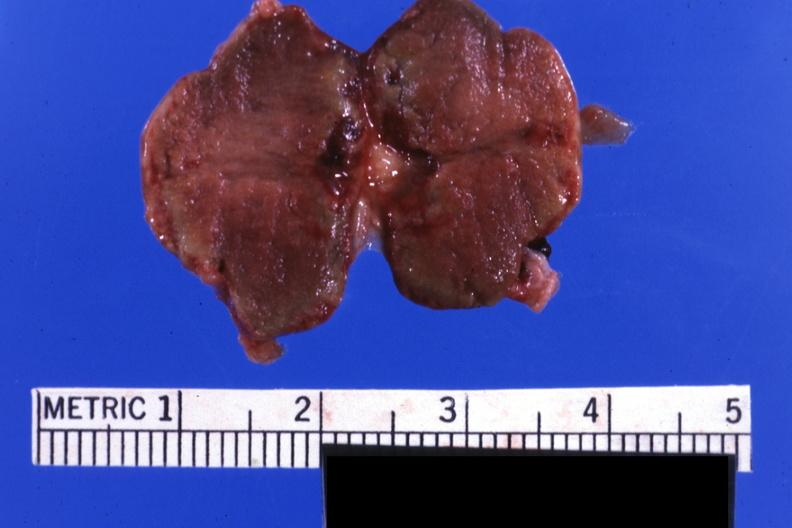what is present?
Answer the question using a single word or phrase. Pituitary 